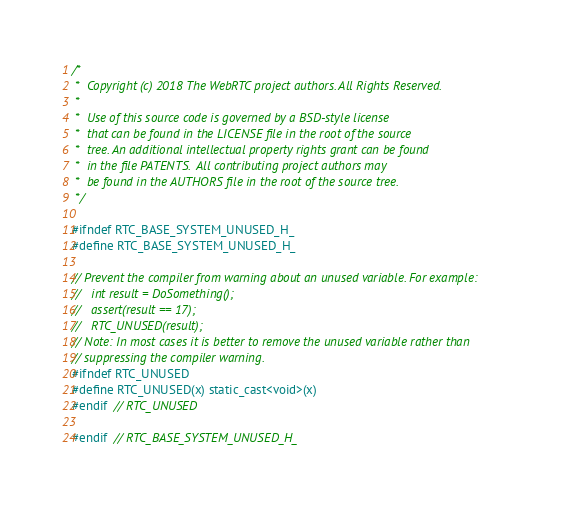<code> <loc_0><loc_0><loc_500><loc_500><_C_>/*
 *  Copyright (c) 2018 The WebRTC project authors. All Rights Reserved.
 *
 *  Use of this source code is governed by a BSD-style license
 *  that can be found in the LICENSE file in the root of the source
 *  tree. An additional intellectual property rights grant can be found
 *  in the file PATENTS.  All contributing project authors may
 *  be found in the AUTHORS file in the root of the source tree.
 */

#ifndef RTC_BASE_SYSTEM_UNUSED_H_
#define RTC_BASE_SYSTEM_UNUSED_H_

// Prevent the compiler from warning about an unused variable. For example:
//   int result = DoSomething();
//   assert(result == 17);
//   RTC_UNUSED(result);
// Note: In most cases it is better to remove the unused variable rather than
// suppressing the compiler warning.
#ifndef RTC_UNUSED
#define RTC_UNUSED(x) static_cast<void>(x)
#endif  // RTC_UNUSED

#endif  // RTC_BASE_SYSTEM_UNUSED_H_
</code> 